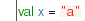Convert code to text. <code><loc_0><loc_0><loc_500><loc_500><_SML_>val x = "a"
</code> 